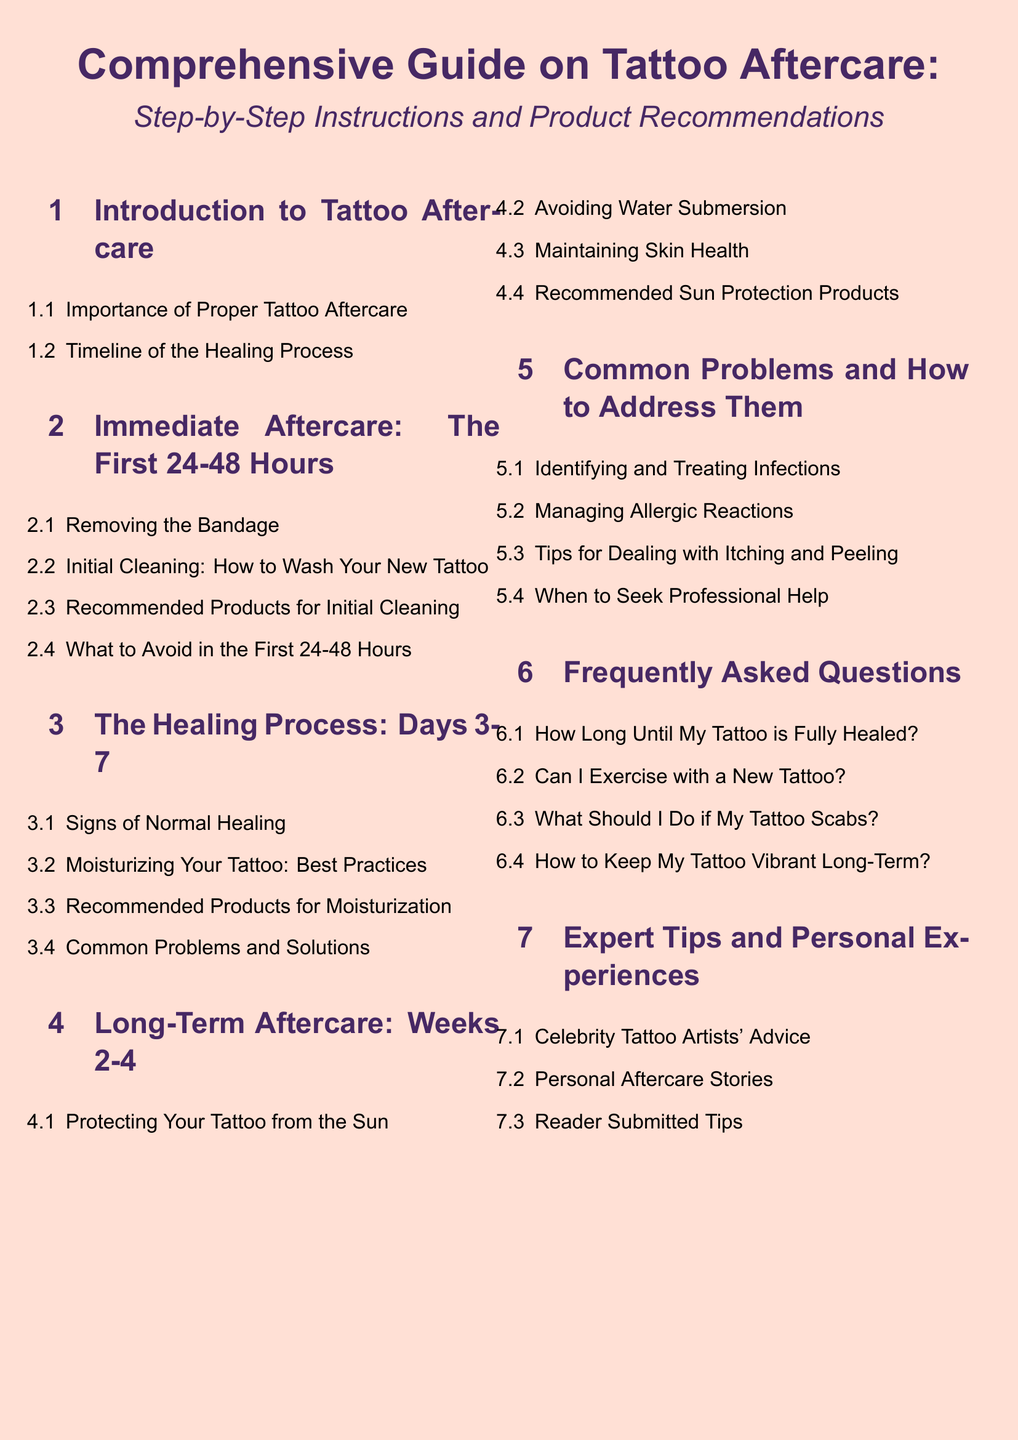What is the focus of the guide? The focus of the guide is to provide step-by-step instructions and product recommendations for tattoo aftercare.
Answer: Step-by-step instructions and product recommendations What is covered in section 1.1? Section 1.1 discusses the importance of proper tattoo aftercare.
Answer: Importance of Proper Tattoo Aftercare What should you avoid in the first 24-48 hours? The document suggests to avoid certain activities or products mentioned in section 2.4.
Answer: What to Avoid in the First 24-48 Hours What are the healing signs addressed in section 3.1? Section 3.1 identifies signs of normal healing during the healing process.
Answer: Signs of Normal Healing What is the recommended action for protecting your tattoo from the sun? Section 4.1 advises on protecting your tattoo from the sun.
Answer: Protecting Your Tattoo from the Sun When should professional help be sought according to the document? Section 5.4 states when to seek professional help regarding tattoo care.
Answer: When to Seek Professional Help How long does it take for a tattoo to fully heal according to section 6.1? Section 6.1 addresses the healing timeline for tattoos.
Answer: How Long Until My Tattoo is Fully Healed? Who provides advice in section 7.1? Section 7.1 features advice from celebrity tattoo artists.
Answer: Celebrity Tattoo Artists' Advice What does section 6.4 discuss? Section 6.4 provides tips on keeping a tattoo vibrant long-term.
Answer: How to Keep My Tattoo Vibrant Long-Term? 